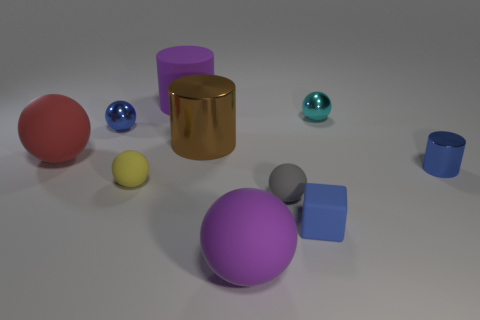Subtract all yellow balls. How many balls are left? 5 Subtract all tiny gray rubber spheres. How many spheres are left? 5 Subtract all green spheres. Subtract all yellow blocks. How many spheres are left? 6 Subtract all spheres. How many objects are left? 4 Add 9 small cyan metallic balls. How many small cyan metallic balls exist? 10 Subtract 0 cyan blocks. How many objects are left? 10 Subtract all blue rubber balls. Subtract all purple rubber balls. How many objects are left? 9 Add 3 red objects. How many red objects are left? 4 